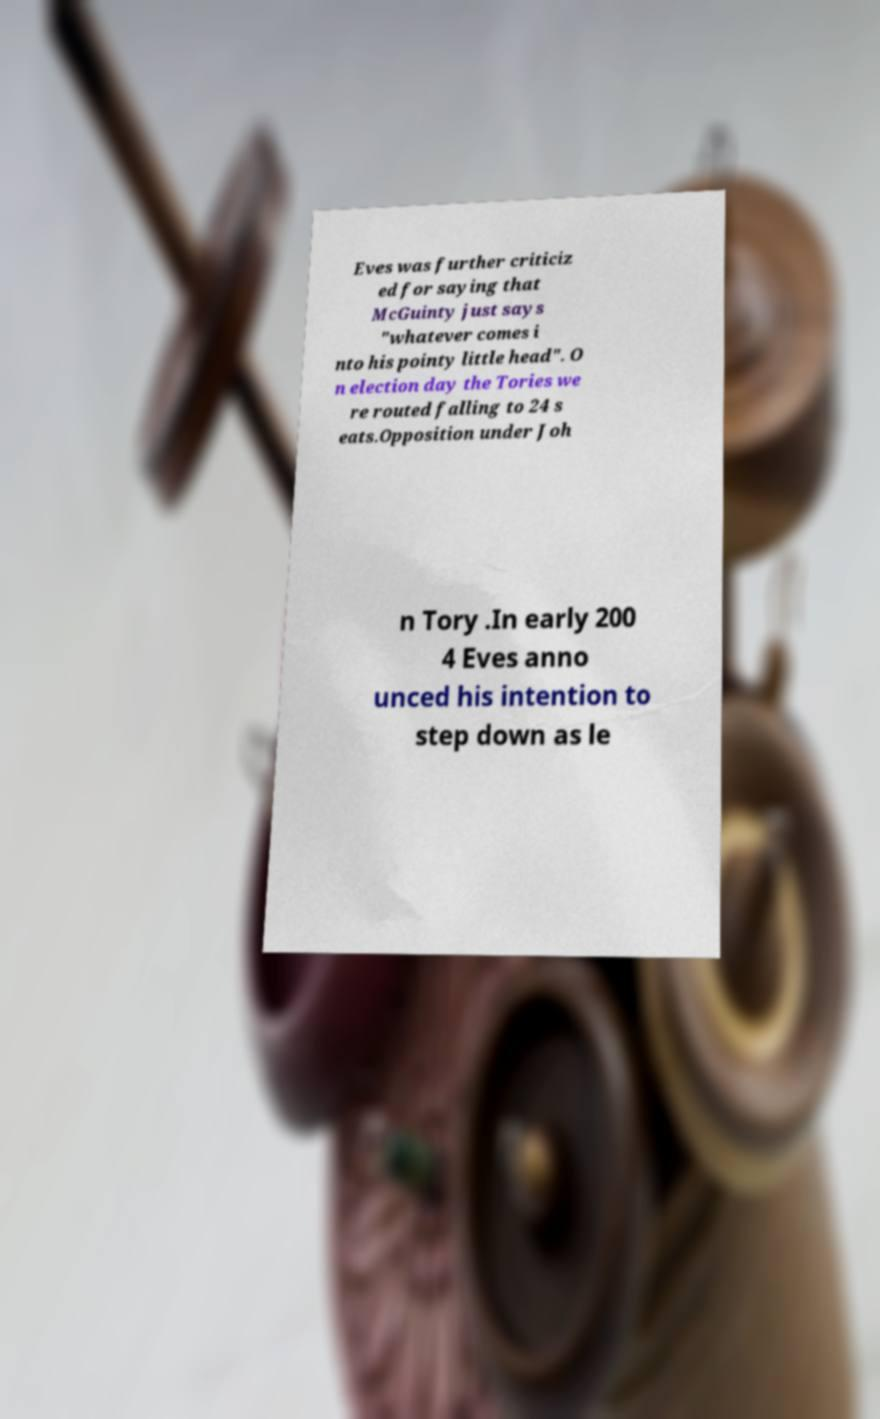I need the written content from this picture converted into text. Can you do that? Eves was further criticiz ed for saying that McGuinty just says "whatever comes i nto his pointy little head". O n election day the Tories we re routed falling to 24 s eats.Opposition under Joh n Tory .In early 200 4 Eves anno unced his intention to step down as le 